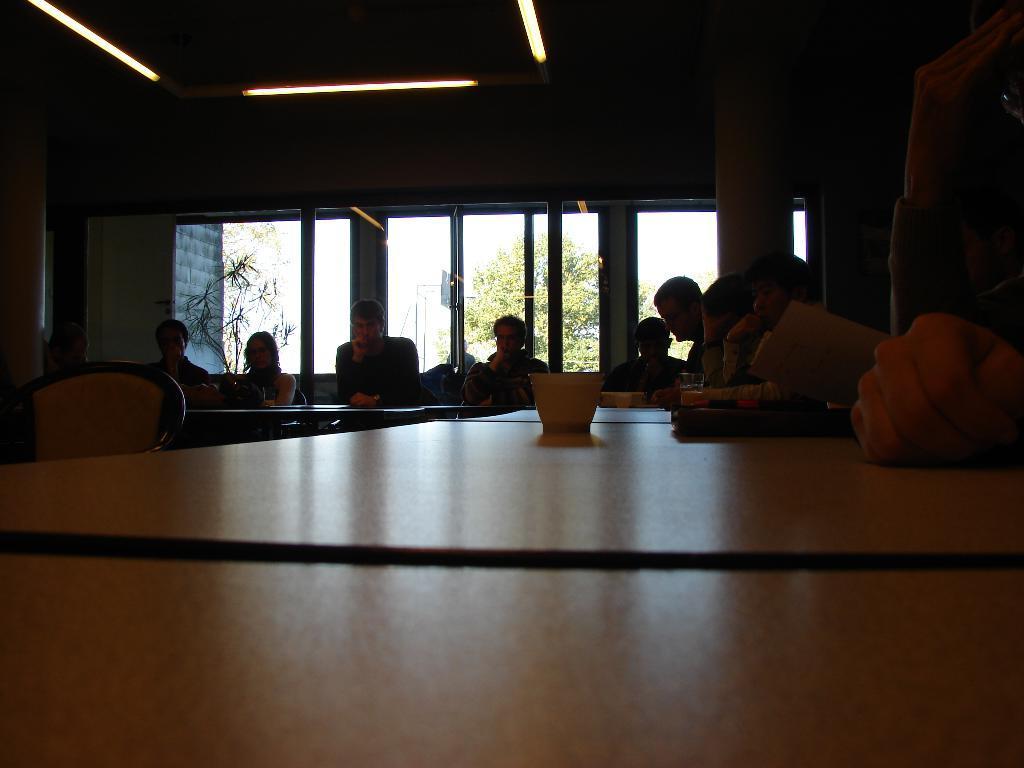In one or two sentences, can you explain what this image depicts? In this image there are group of persons sitting, there are tables, there is an object on the table, there are chairs, there are windows, there is a tree, there is the sky, there is a wall, there is roof towards the top of the image, there are lights towards the top of the image, there are pillars. 